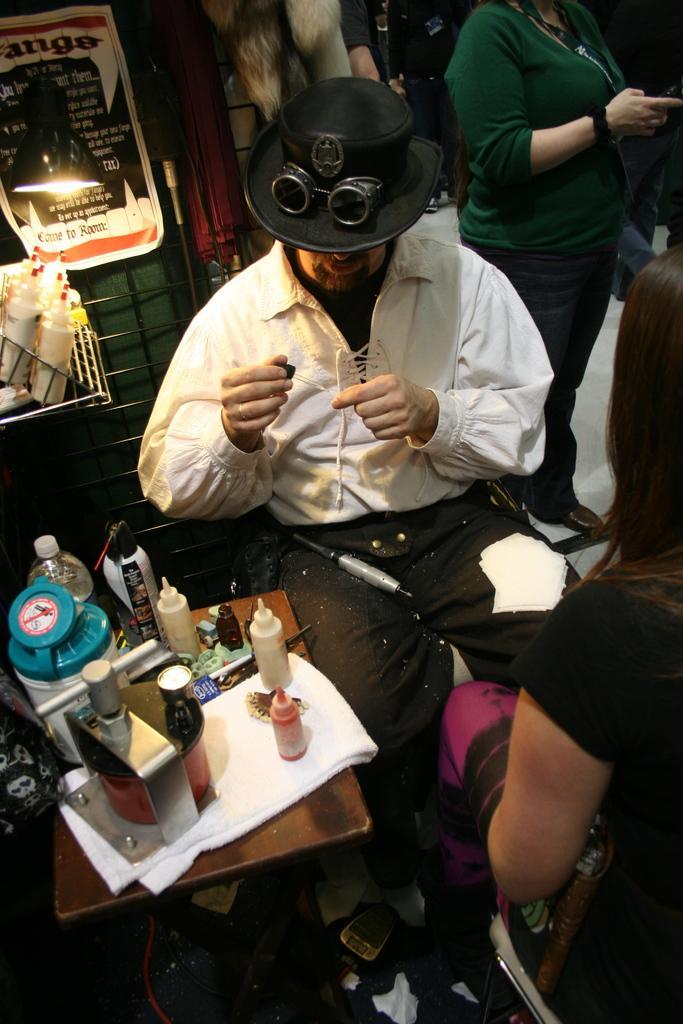Describe this image in one or two sentences. There is a person in white color shirt, holding an object, sitting on a chair, in front of a woman who is sitting on another chair, near a table, on which, there are bottles and other objects. In the background, there are other persons standing and there are other objects. 